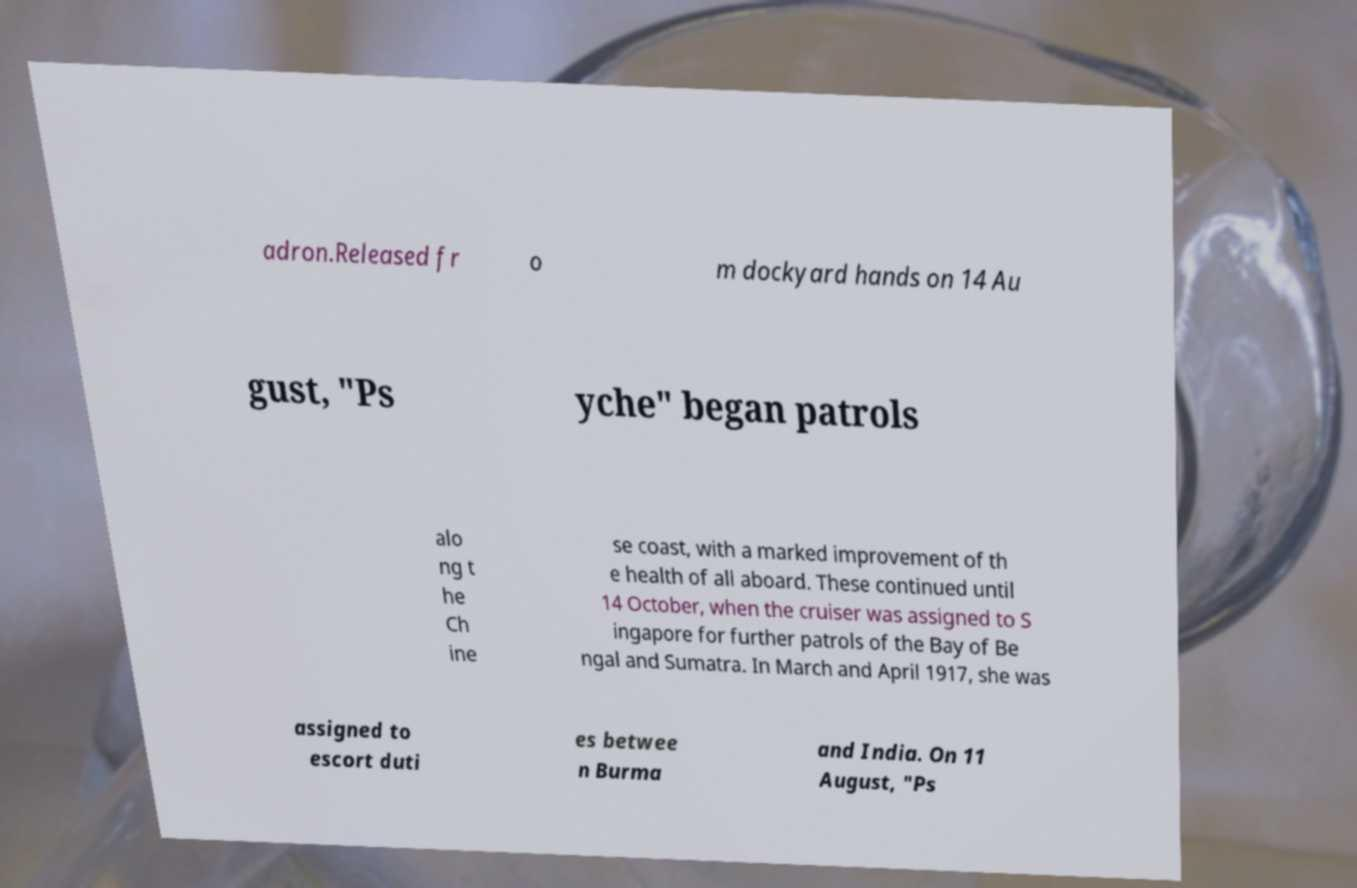Could you assist in decoding the text presented in this image and type it out clearly? adron.Released fr o m dockyard hands on 14 Au gust, "Ps yche" began patrols alo ng t he Ch ine se coast, with a marked improvement of th e health of all aboard. These continued until 14 October, when the cruiser was assigned to S ingapore for further patrols of the Bay of Be ngal and Sumatra. In March and April 1917, she was assigned to escort duti es betwee n Burma and India. On 11 August, "Ps 